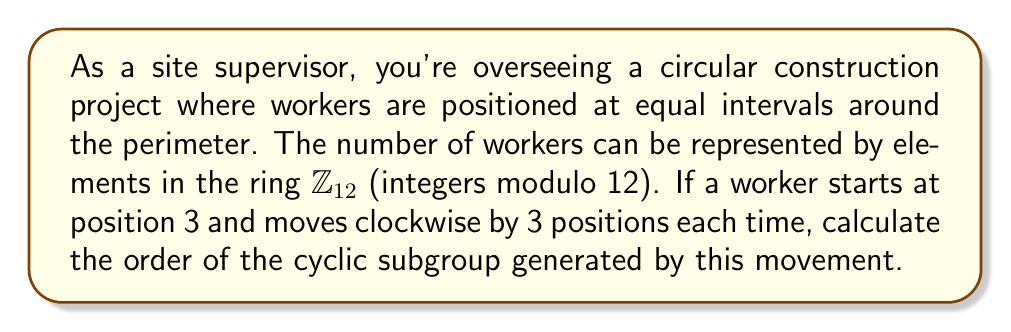What is the answer to this math problem? To solve this problem, we need to understand the concept of cyclic subgroups in a ring and how to calculate their order. Let's approach this step-by-step:

1) In the ring $\mathbb{Z}_{12}$, we're considering the element 3.

2) The cyclic subgroup generated by 3 is:
   $\langle 3 \rangle = \{3, 6, 9, 0, 3, 6, 9, 0, ...\}$

3) To find the order of this subgroup, we need to determine how many unique elements appear before the pattern repeats.

4) Let's calculate the multiples of 3 modulo 12:
   $3 \cdot 1 \equiv 3 \pmod{12}$
   $3 \cdot 2 \equiv 6 \pmod{12}$
   $3 \cdot 3 \equiv 9 \pmod{12}$
   $3 \cdot 4 \equiv 0 \pmod{12}$

5) We see that after four steps, we're back to 0, and the pattern will repeat.

6) Therefore, the unique elements in the subgroup are $\{3, 6, 9, 0\}$.

7) The number of these unique elements is the order of the subgroup.

Thus, the order of the cyclic subgroup $\langle 3 \rangle$ in $\mathbb{Z}_{12}$ is 4.

In terms of the construction site, this means the worker will return to their starting position after moving 4 times.
Answer: The order of the cyclic subgroup $\langle 3 \rangle$ in $\mathbb{Z}_{12}$ is 4. 